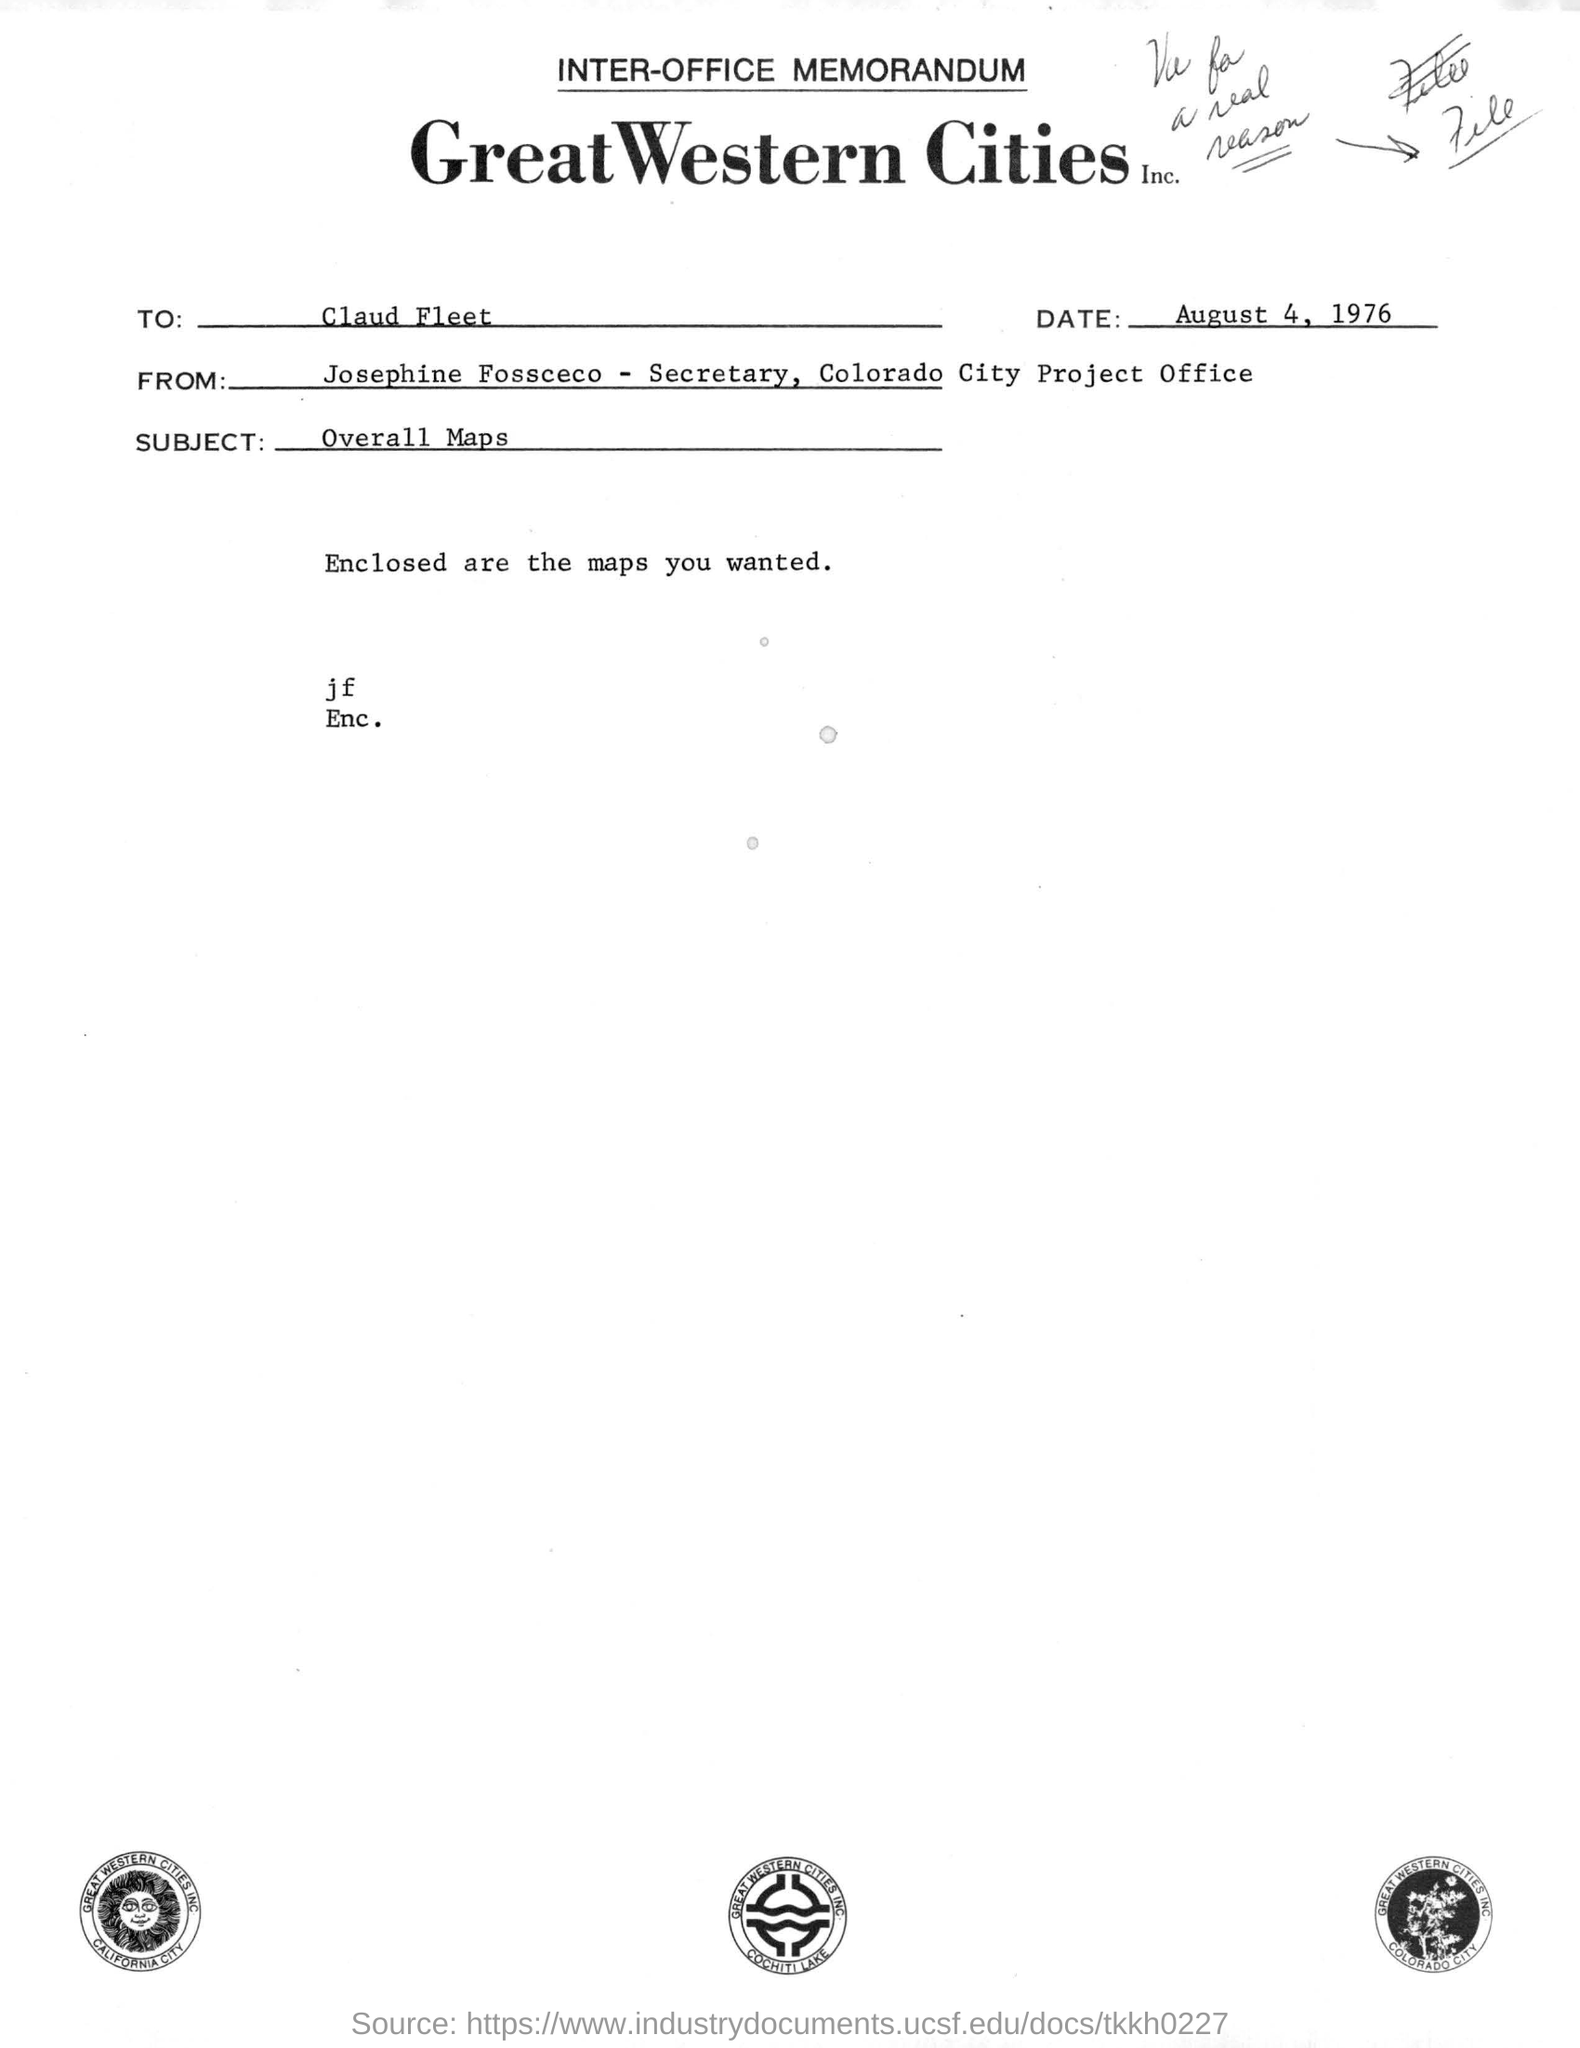What is the date mentioned in the memorandum?
Your response must be concise. August 4, 1976. To whom this letter is addressed?
Provide a succinct answer. Claud fleet. What is the date of the document?
Your answer should be very brief. August 4, 1976. What is the subject of this letter?
Your response must be concise. Overall maps. What is enclosed along with this letter?
Give a very brief answer. Maps. 